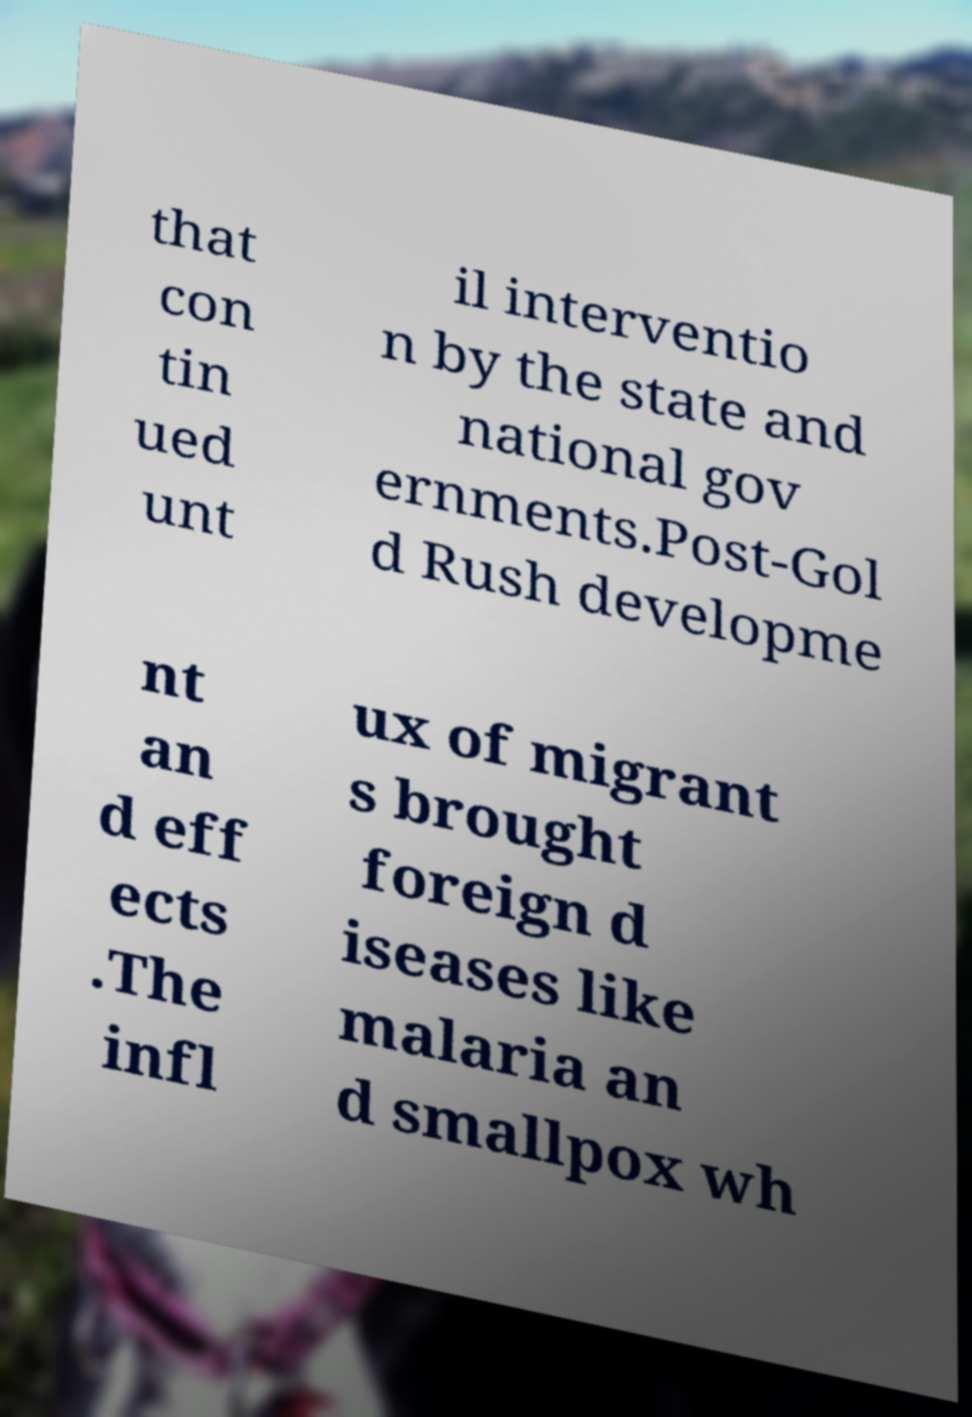There's text embedded in this image that I need extracted. Can you transcribe it verbatim? that con tin ued unt il interventio n by the state and national gov ernments.Post-Gol d Rush developme nt an d eff ects .The infl ux of migrant s brought foreign d iseases like malaria an d smallpox wh 